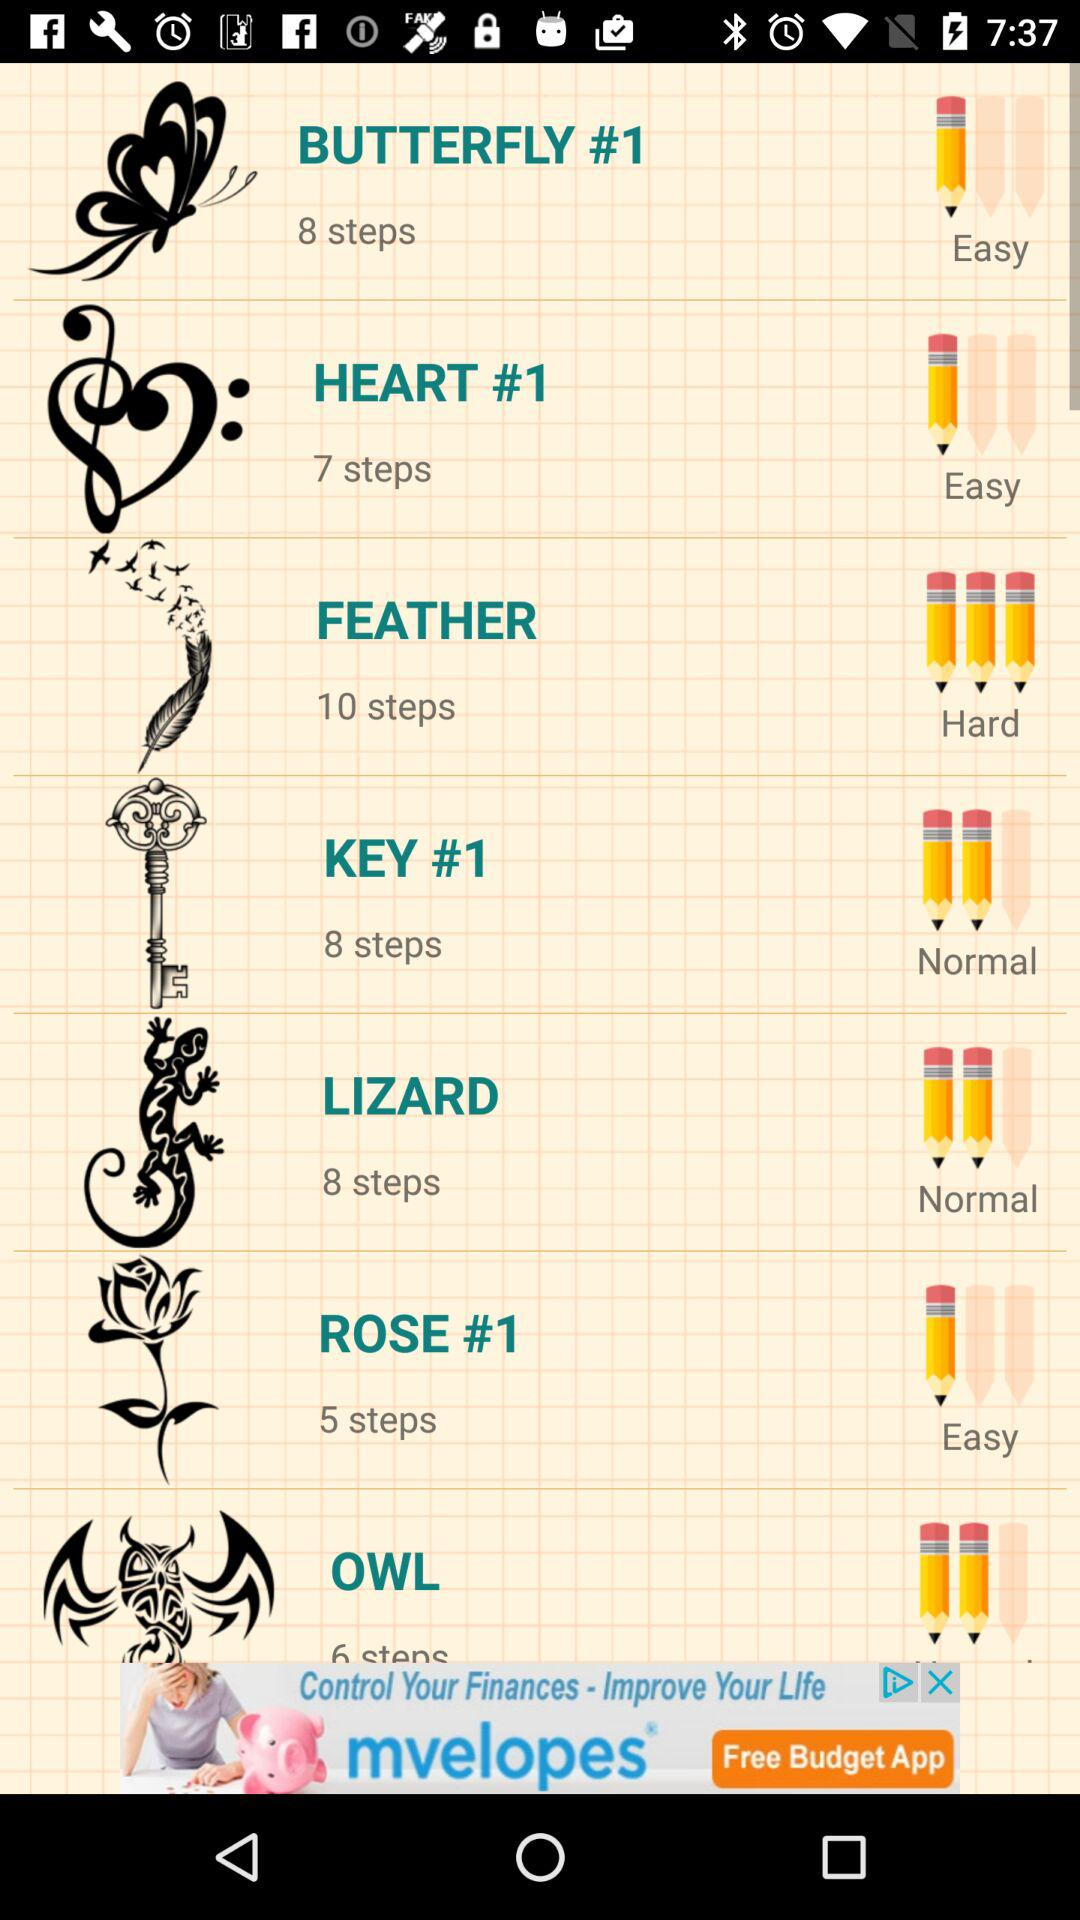What is the number of the steps in the key? The number of steps is 8. 